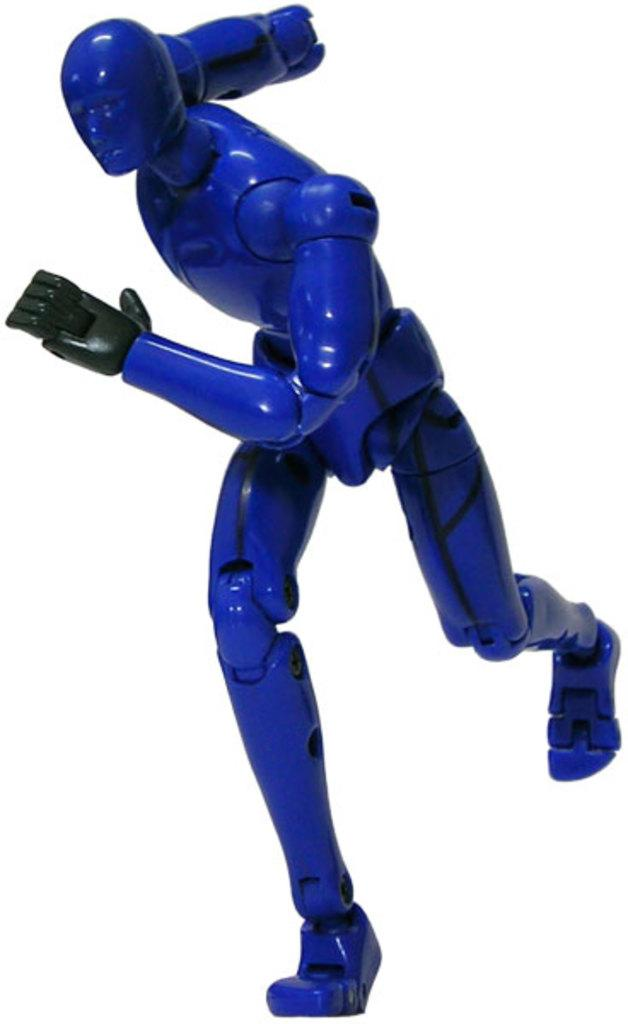What is the main subject of the image? There is a toy robot in the image. What color is the toy robot? The toy robot is blue in color. What color is the background of the image? The background of the image is white. How many clovers are growing on the toy robot in the image? There are no clovers present in the image, as it features a toy robot. 